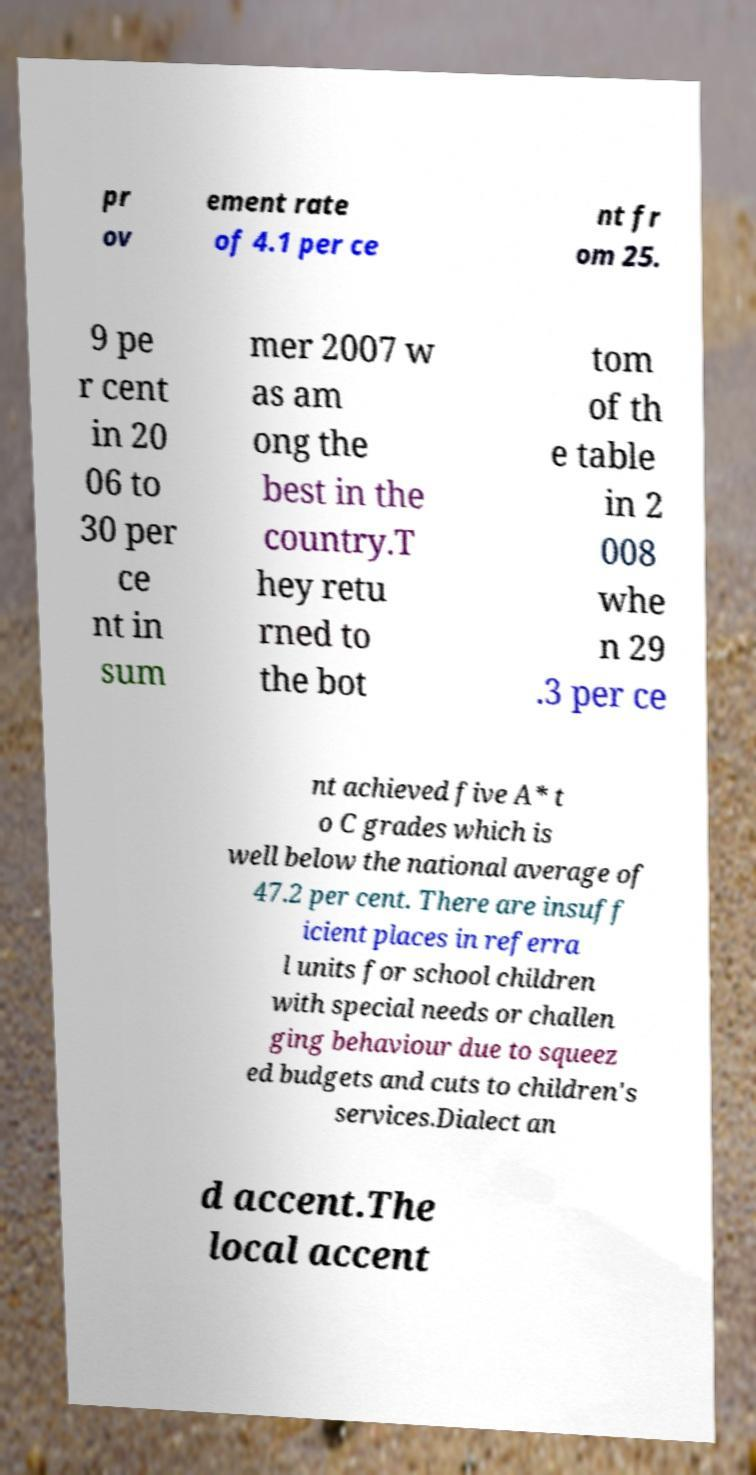For documentation purposes, I need the text within this image transcribed. Could you provide that? pr ov ement rate of 4.1 per ce nt fr om 25. 9 pe r cent in 20 06 to 30 per ce nt in sum mer 2007 w as am ong the best in the country.T hey retu rned to the bot tom of th e table in 2 008 whe n 29 .3 per ce nt achieved five A* t o C grades which is well below the national average of 47.2 per cent. There are insuff icient places in referra l units for school children with special needs or challen ging behaviour due to squeez ed budgets and cuts to children's services.Dialect an d accent.The local accent 